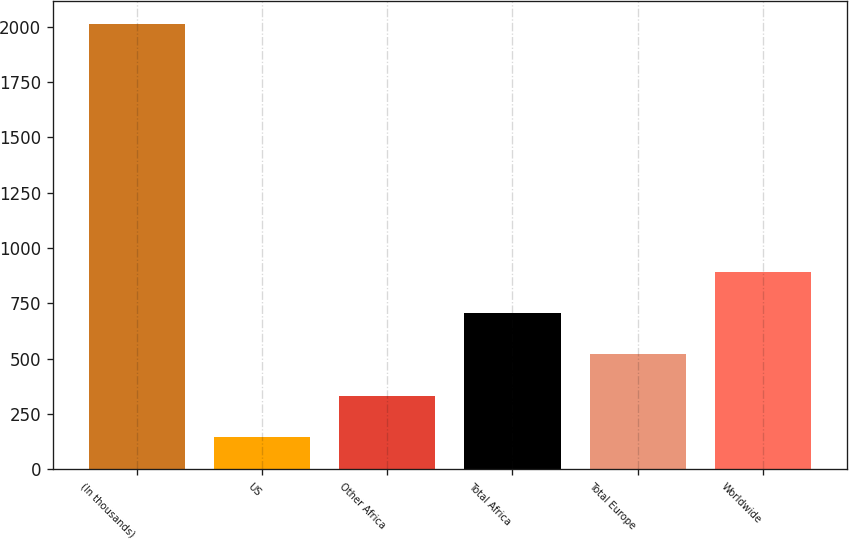Convert chart. <chart><loc_0><loc_0><loc_500><loc_500><bar_chart><fcel>(In thousands)<fcel>US<fcel>Other Africa<fcel>Total Africa<fcel>Total Europe<fcel>Worldwide<nl><fcel>2014<fcel>145<fcel>331.9<fcel>705.7<fcel>518.8<fcel>892.6<nl></chart> 